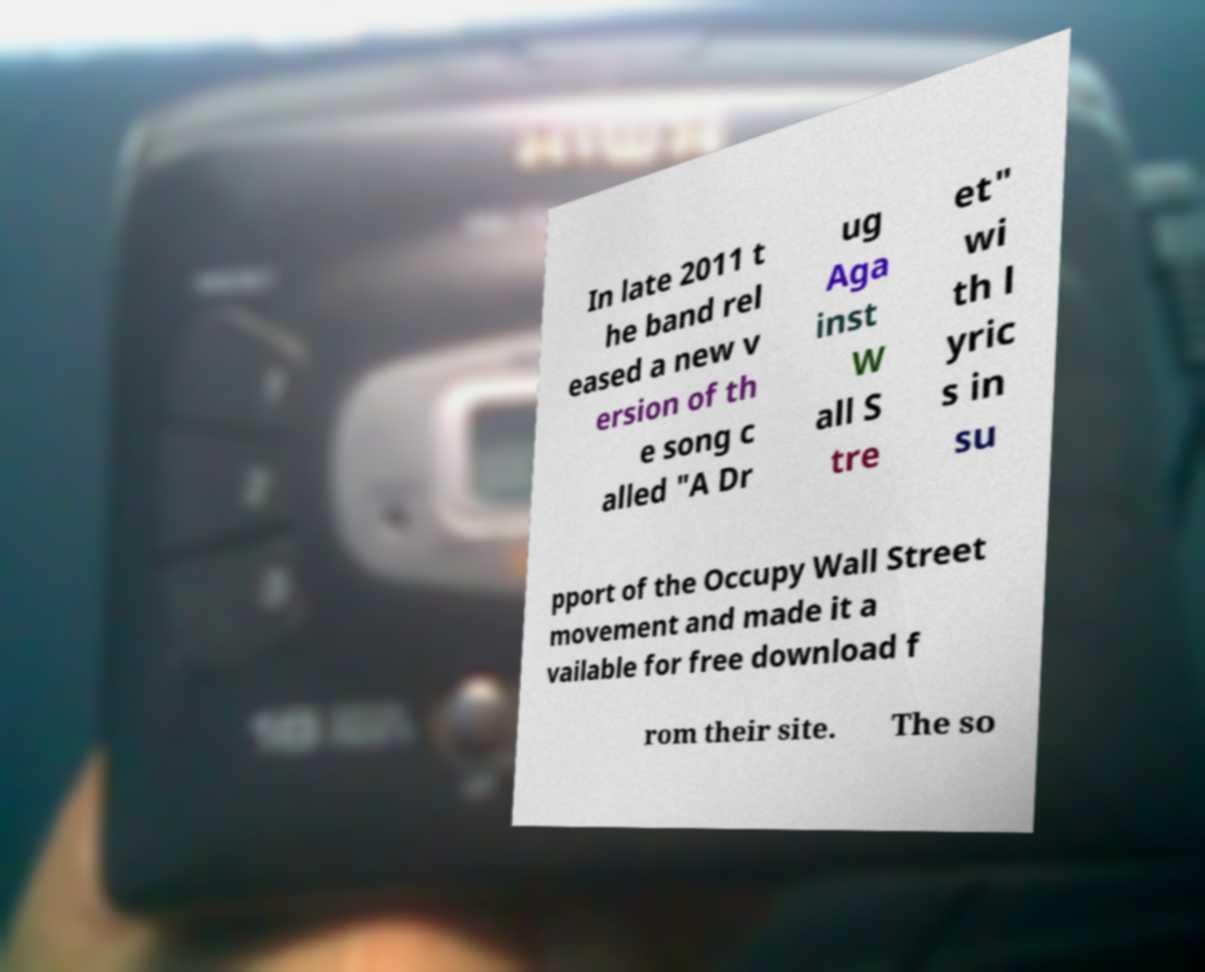Please read and relay the text visible in this image. What does it say? In late 2011 t he band rel eased a new v ersion of th e song c alled "A Dr ug Aga inst W all S tre et" wi th l yric s in su pport of the Occupy Wall Street movement and made it a vailable for free download f rom their site. The so 